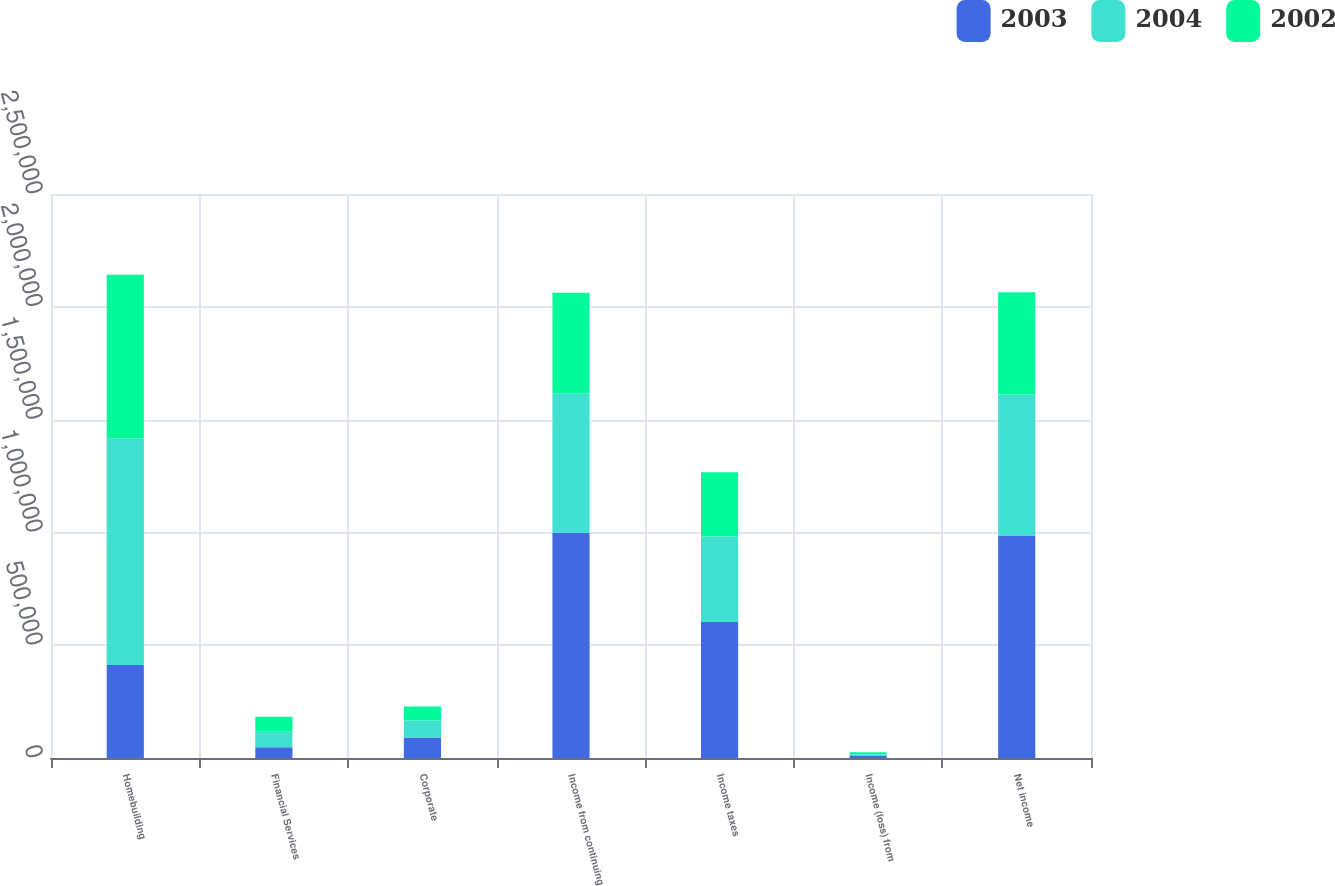Convert chart. <chart><loc_0><loc_0><loc_500><loc_500><stacked_bar_chart><ecel><fcel>Homebuilding<fcel>Financial Services<fcel>Corporate<fcel>Income from continuing<fcel>Income taxes<fcel>Income (loss) from<fcel>Net income<nl><fcel>2003<fcel>412080<fcel>47429<fcel>90685<fcel>998008<fcel>602529<fcel>11467<fcel>986541<nl><fcel>2004<fcel>1.00512e+06<fcel>68846<fcel>75351<fcel>619243<fcel>379376<fcel>5391<fcel>624634<nl><fcel>2002<fcel>724369<fcel>66723<fcel>61968<fcel>444785<fcel>284339<fcel>8860<fcel>453645<nl></chart> 